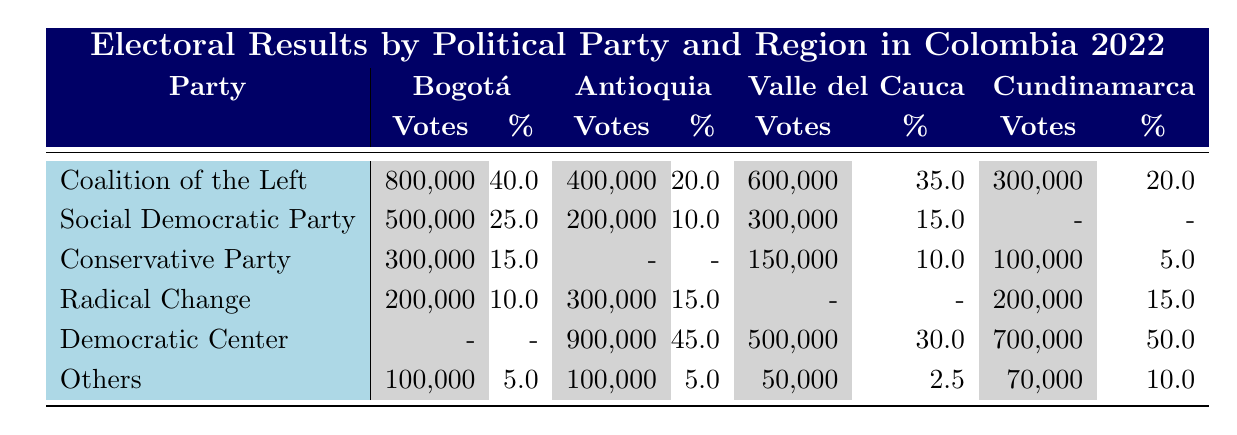What political party received the most votes in Bogotá? The party with the highest votes in Bogotá is the Coalition of the Left with 800,000 votes.
Answer: Coalition of the Left What is the percentage of votes for the Democratic Center in Cundinamarca? In Cundinamarca, the Democratic Center received 50% of the votes.
Answer: 50% Which party had a percentage of votes below 10% in Valle del Cauca? The party with a percentage below 10% in Valle del Cauca is "Others" with 2.5%.
Answer: Others If we sum the votes of the Coalition of the Left across all regions, what is the total? The Coalition of the Left received 800,000 (Bogotá) + 400,000 (Antioquia) + 600,000 (Valle del Cauca) + 300,000 (Cundinamarca) = 2,100,000 votes total.
Answer: 2,100,000 Is the Social Democratic Party more popular in Bogotá than in Antioquia? Yes, the Social Democratic Party received 500,000 votes (25%) in Bogotá and only 200,000 votes (10%) in Antioquia.
Answer: Yes What is the average percentage of votes for the Conservative Party across all regions? The Conservative Party received 15% in Bogotá, 0% in Antioquia, 10% in Valle del Cauca, and 5% in Cundinamarca. The average is (15 + 0 + 10 + 5) / 4 = 7.5%.
Answer: 7.5% Which region had the lowest total votes for the party "Others"? Valle del Cauca had the lowest votes for "Others" with 50,000 votes.
Answer: Valle del Cauca How many votes did Radical Change receive in total across all regions? Radical Change received 200,000 votes (Bogotá) + 300,000 votes (Antioquia) + 0 votes (Valle del Cauca) + 200,000 votes (Cundinamarca) = 700,000 votes total.
Answer: 700,000 Did any party receive the same percentage of votes in two different regions? Yes, the Coalition of the Left received 20% in both Bogotá and Cundinamarca.
Answer: Yes 